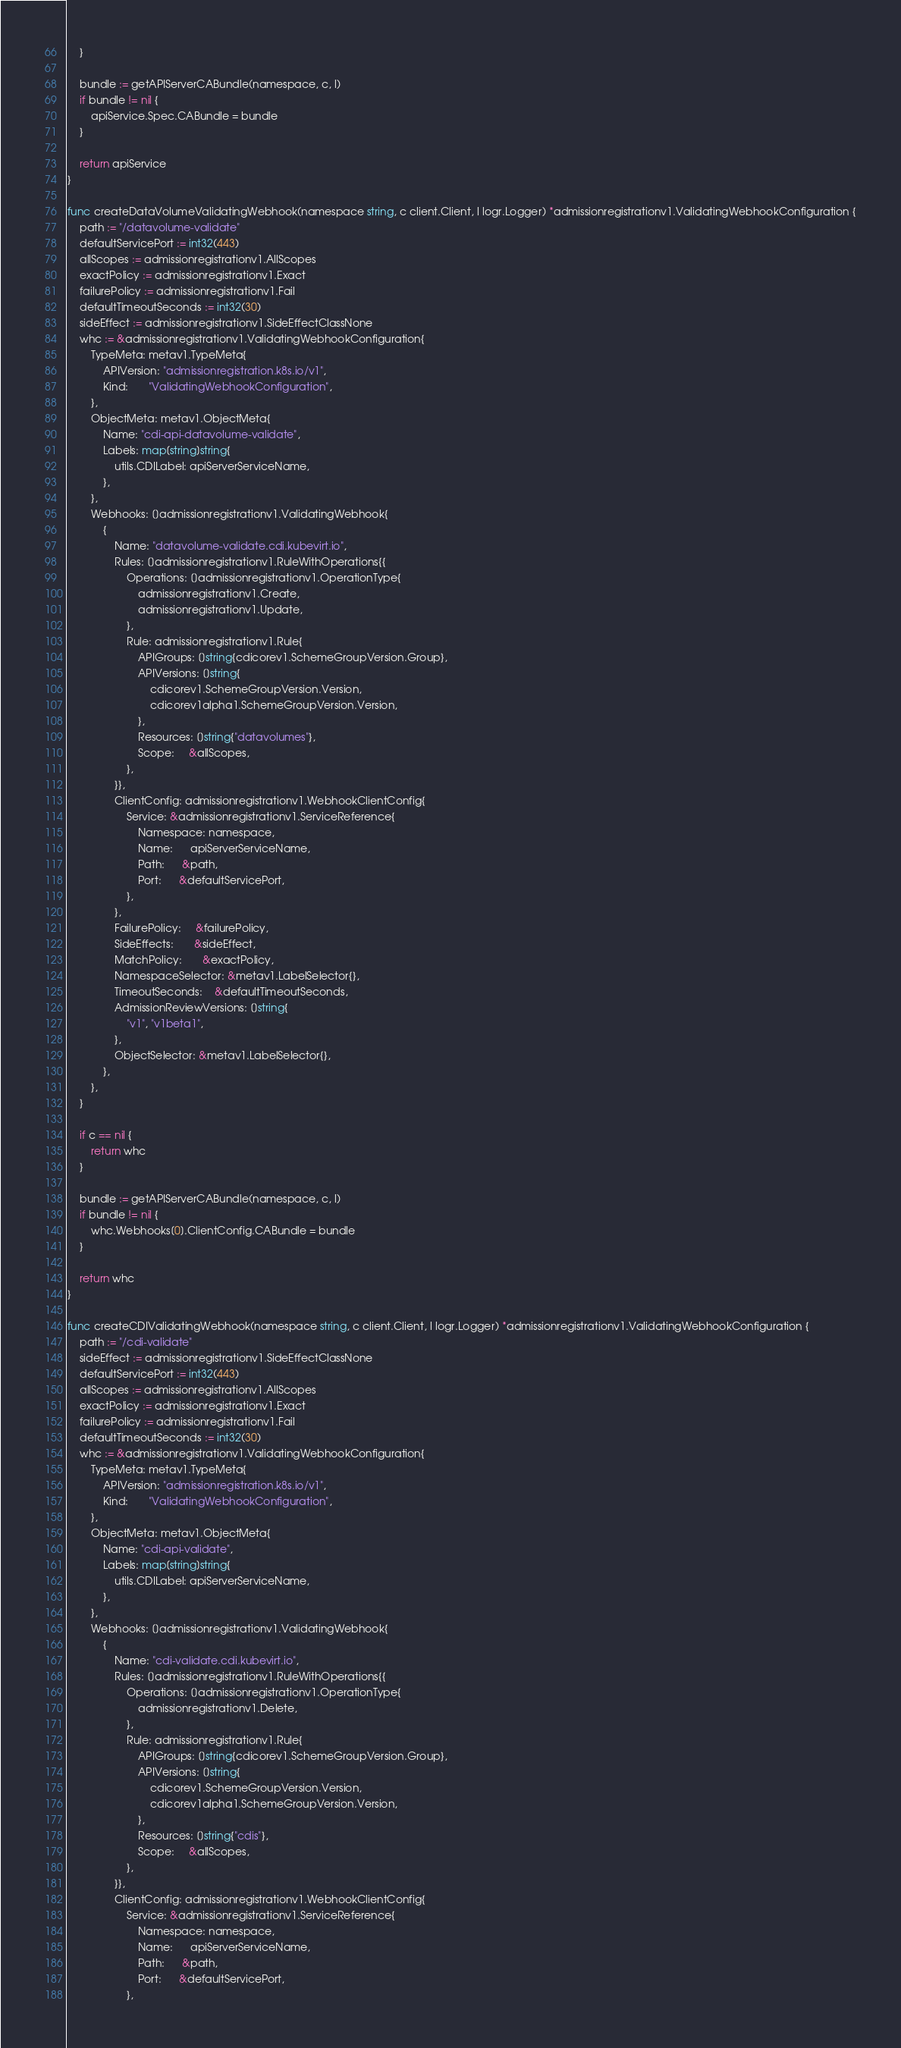Convert code to text. <code><loc_0><loc_0><loc_500><loc_500><_Go_>	}

	bundle := getAPIServerCABundle(namespace, c, l)
	if bundle != nil {
		apiService.Spec.CABundle = bundle
	}

	return apiService
}

func createDataVolumeValidatingWebhook(namespace string, c client.Client, l logr.Logger) *admissionregistrationv1.ValidatingWebhookConfiguration {
	path := "/datavolume-validate"
	defaultServicePort := int32(443)
	allScopes := admissionregistrationv1.AllScopes
	exactPolicy := admissionregistrationv1.Exact
	failurePolicy := admissionregistrationv1.Fail
	defaultTimeoutSeconds := int32(30)
	sideEffect := admissionregistrationv1.SideEffectClassNone
	whc := &admissionregistrationv1.ValidatingWebhookConfiguration{
		TypeMeta: metav1.TypeMeta{
			APIVersion: "admissionregistration.k8s.io/v1",
			Kind:       "ValidatingWebhookConfiguration",
		},
		ObjectMeta: metav1.ObjectMeta{
			Name: "cdi-api-datavolume-validate",
			Labels: map[string]string{
				utils.CDILabel: apiServerServiceName,
			},
		},
		Webhooks: []admissionregistrationv1.ValidatingWebhook{
			{
				Name: "datavolume-validate.cdi.kubevirt.io",
				Rules: []admissionregistrationv1.RuleWithOperations{{
					Operations: []admissionregistrationv1.OperationType{
						admissionregistrationv1.Create,
						admissionregistrationv1.Update,
					},
					Rule: admissionregistrationv1.Rule{
						APIGroups: []string{cdicorev1.SchemeGroupVersion.Group},
						APIVersions: []string{
							cdicorev1.SchemeGroupVersion.Version,
							cdicorev1alpha1.SchemeGroupVersion.Version,
						},
						Resources: []string{"datavolumes"},
						Scope:     &allScopes,
					},
				}},
				ClientConfig: admissionregistrationv1.WebhookClientConfig{
					Service: &admissionregistrationv1.ServiceReference{
						Namespace: namespace,
						Name:      apiServerServiceName,
						Path:      &path,
						Port:      &defaultServicePort,
					},
				},
				FailurePolicy:     &failurePolicy,
				SideEffects:       &sideEffect,
				MatchPolicy:       &exactPolicy,
				NamespaceSelector: &metav1.LabelSelector{},
				TimeoutSeconds:    &defaultTimeoutSeconds,
				AdmissionReviewVersions: []string{
					"v1", "v1beta1",
				},
				ObjectSelector: &metav1.LabelSelector{},
			},
		},
	}

	if c == nil {
		return whc
	}

	bundle := getAPIServerCABundle(namespace, c, l)
	if bundle != nil {
		whc.Webhooks[0].ClientConfig.CABundle = bundle
	}

	return whc
}

func createCDIValidatingWebhook(namespace string, c client.Client, l logr.Logger) *admissionregistrationv1.ValidatingWebhookConfiguration {
	path := "/cdi-validate"
	sideEffect := admissionregistrationv1.SideEffectClassNone
	defaultServicePort := int32(443)
	allScopes := admissionregistrationv1.AllScopes
	exactPolicy := admissionregistrationv1.Exact
	failurePolicy := admissionregistrationv1.Fail
	defaultTimeoutSeconds := int32(30)
	whc := &admissionregistrationv1.ValidatingWebhookConfiguration{
		TypeMeta: metav1.TypeMeta{
			APIVersion: "admissionregistration.k8s.io/v1",
			Kind:       "ValidatingWebhookConfiguration",
		},
		ObjectMeta: metav1.ObjectMeta{
			Name: "cdi-api-validate",
			Labels: map[string]string{
				utils.CDILabel: apiServerServiceName,
			},
		},
		Webhooks: []admissionregistrationv1.ValidatingWebhook{
			{
				Name: "cdi-validate.cdi.kubevirt.io",
				Rules: []admissionregistrationv1.RuleWithOperations{{
					Operations: []admissionregistrationv1.OperationType{
						admissionregistrationv1.Delete,
					},
					Rule: admissionregistrationv1.Rule{
						APIGroups: []string{cdicorev1.SchemeGroupVersion.Group},
						APIVersions: []string{
							cdicorev1.SchemeGroupVersion.Version,
							cdicorev1alpha1.SchemeGroupVersion.Version,
						},
						Resources: []string{"cdis"},
						Scope:     &allScopes,
					},
				}},
				ClientConfig: admissionregistrationv1.WebhookClientConfig{
					Service: &admissionregistrationv1.ServiceReference{
						Namespace: namespace,
						Name:      apiServerServiceName,
						Path:      &path,
						Port:      &defaultServicePort,
					},</code> 